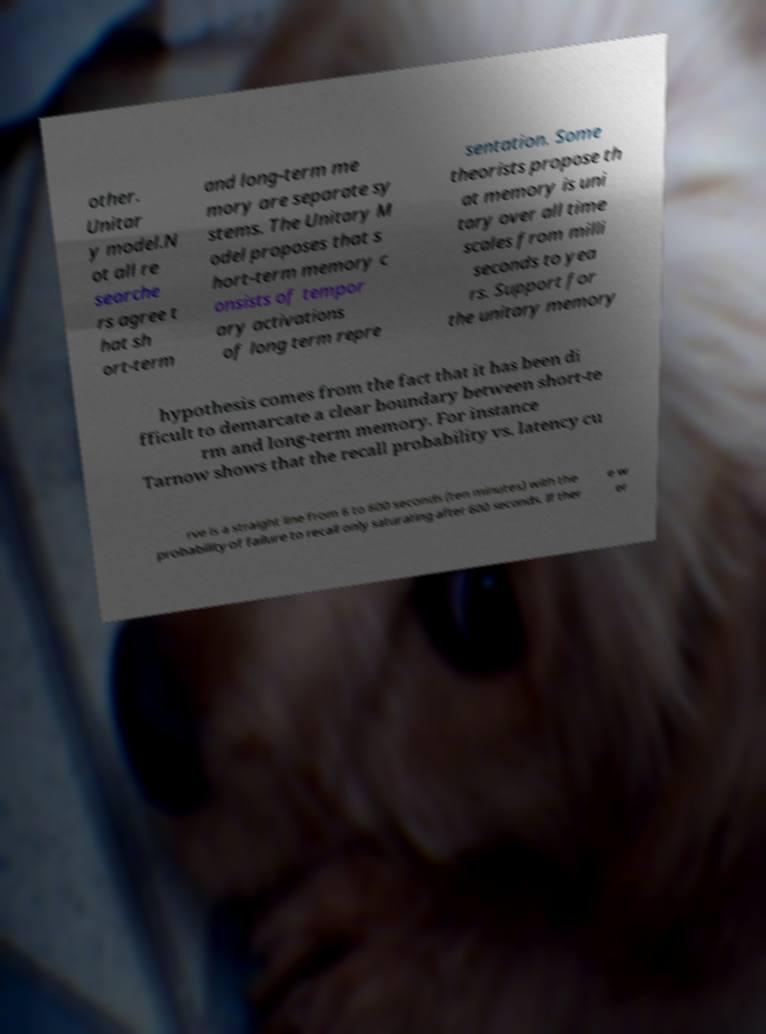Could you assist in decoding the text presented in this image and type it out clearly? other. Unitar y model.N ot all re searche rs agree t hat sh ort-term and long-term me mory are separate sy stems. The Unitary M odel proposes that s hort-term memory c onsists of tempor ary activations of long term repre sentation. Some theorists propose th at memory is uni tary over all time scales from milli seconds to yea rs. Support for the unitary memory hypothesis comes from the fact that it has been di fficult to demarcate a clear boundary between short-te rm and long-term memory. For instance Tarnow shows that the recall probability vs. latency cu rve is a straight line from 6 to 600 seconds (ten minutes) with the probability of failure to recall only saturating after 600 seconds. If ther e w er 